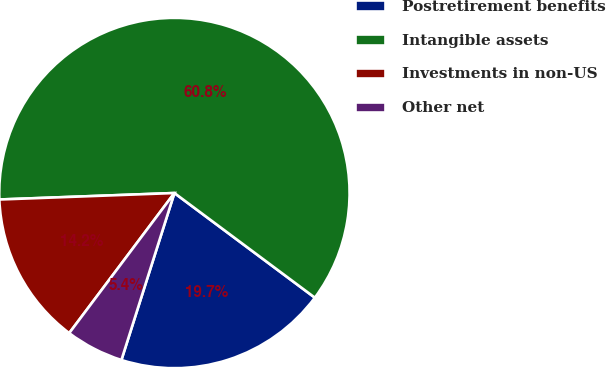<chart> <loc_0><loc_0><loc_500><loc_500><pie_chart><fcel>Postretirement benefits<fcel>Intangible assets<fcel>Investments in non-US<fcel>Other net<nl><fcel>19.7%<fcel>60.78%<fcel>14.16%<fcel>5.36%<nl></chart> 